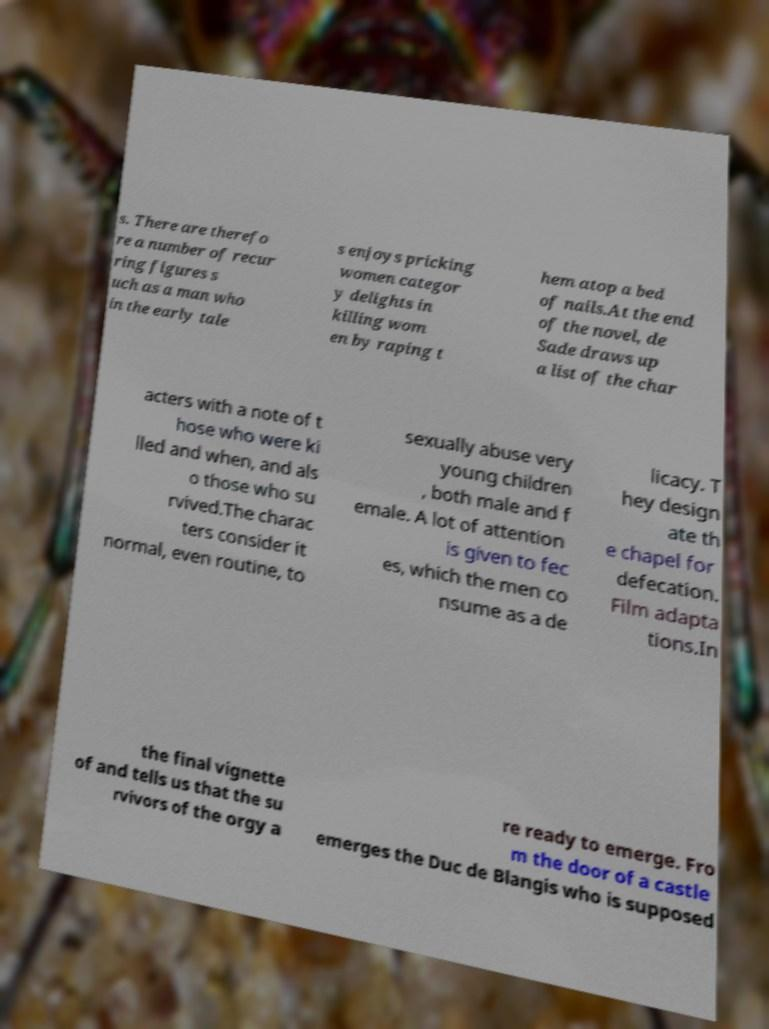Could you extract and type out the text from this image? s. There are therefo re a number of recur ring figures s uch as a man who in the early tale s enjoys pricking women categor y delights in killing wom en by raping t hem atop a bed of nails.At the end of the novel, de Sade draws up a list of the char acters with a note of t hose who were ki lled and when, and als o those who su rvived.The charac ters consider it normal, even routine, to sexually abuse very young children , both male and f emale. A lot of attention is given to fec es, which the men co nsume as a de licacy. T hey design ate th e chapel for defecation. Film adapta tions.In the final vignette of and tells us that the su rvivors of the orgy a re ready to emerge. Fro m the door of a castle emerges the Duc de Blangis who is supposed 